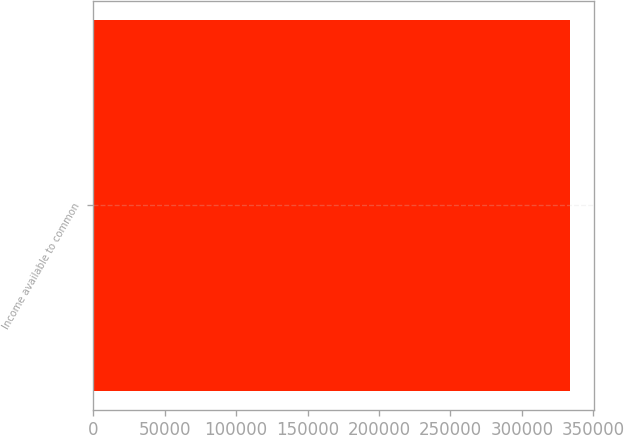<chart> <loc_0><loc_0><loc_500><loc_500><bar_chart><fcel>Income available to common<nl><fcel>333572<nl></chart> 